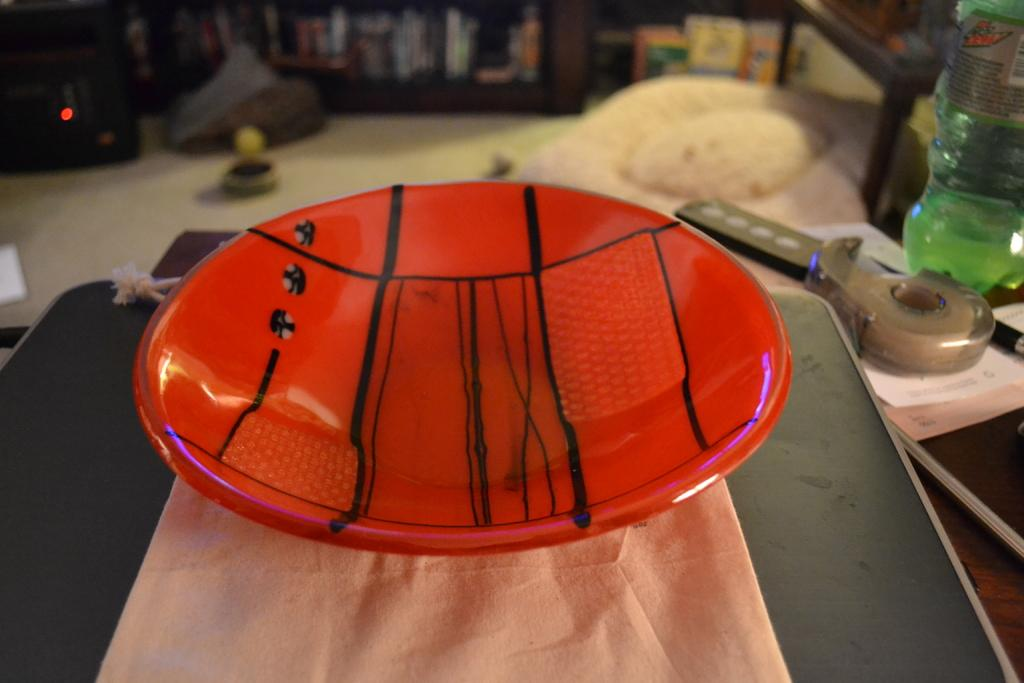What is the primary surface where the objects are placed in the image? The objects are placed on a table in the image. Can you identify any specific objects on the table? Yes, there is a bottle, a plaster, and a book on the table. What type of crayon is being used to draw on the book in the image? There is no crayon or drawing activity present in the image; it only shows objects placed on a table. 